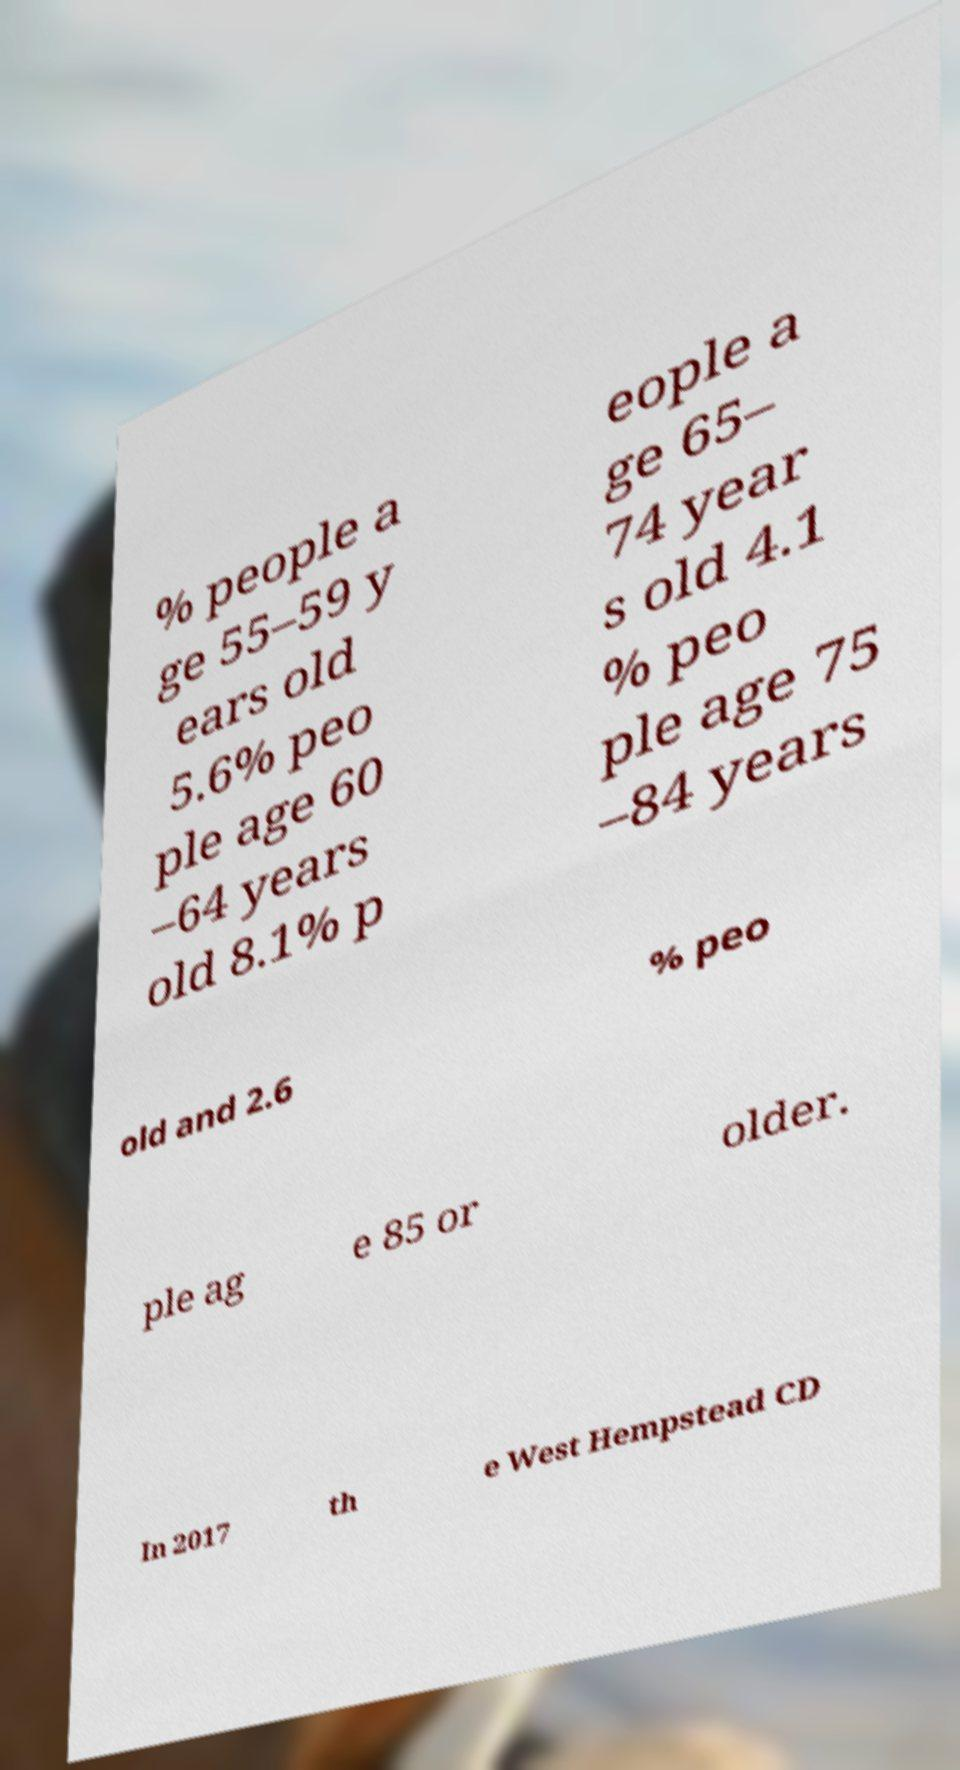Please identify and transcribe the text found in this image. % people a ge 55–59 y ears old 5.6% peo ple age 60 –64 years old 8.1% p eople a ge 65– 74 year s old 4.1 % peo ple age 75 –84 years old and 2.6 % peo ple ag e 85 or older. In 2017 th e West Hempstead CD 